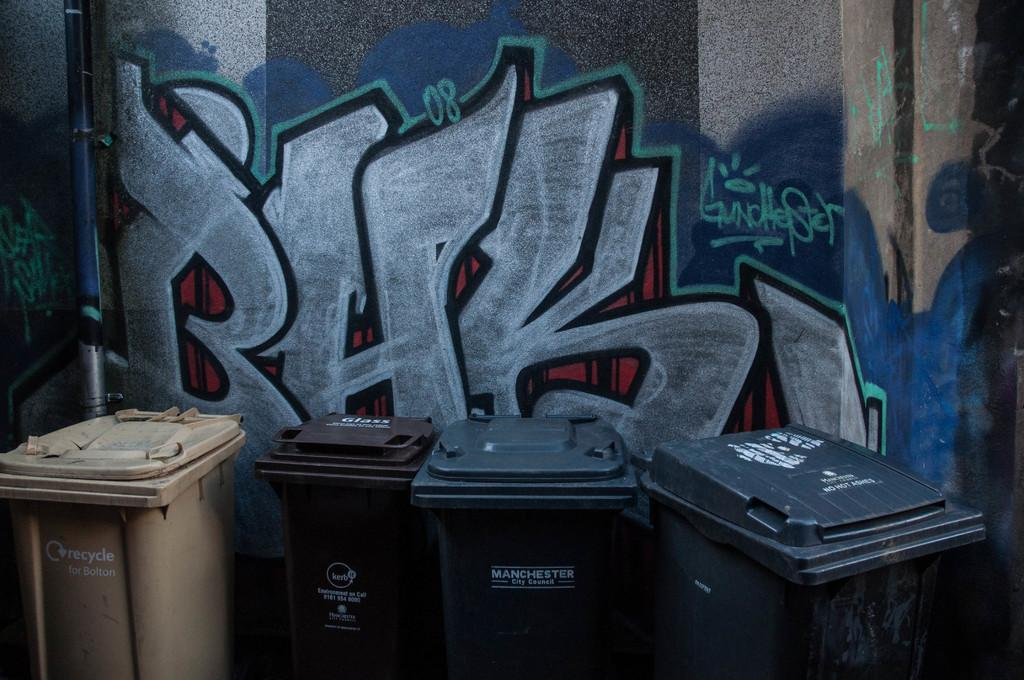<image>
Render a clear and concise summary of the photo. Several trash cans from Manchester are lined up next to each other. 